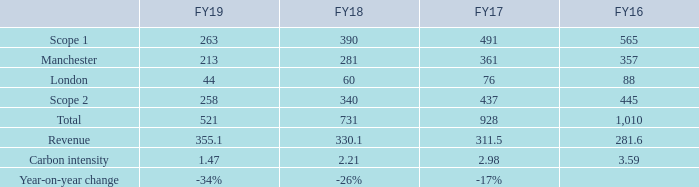Total CO2 emissions FY19
1 Tonnes of carbon dioxide equivalent.
2 Absolute carbon emissions divided by revenue in millions.
Auto Trader is required to measure and
report its direct and indirect greenhouse
gas (‘GHG’) emissions by the Companies Act
2006 (Strategic Report and Directors’ Report)
Regulations 2013. The greenhouse gas
reporting period is aligned to the financial
reporting year. The methodology used to
calculate our emissions is based on the
financial consolidation approach, as
defined in the Greenhouse Gas Protocol,
A Corporate Accounting and Reporting
Standard (Revised Edition). Emission
factors used are from UK government
(‘BEIS’) conversion factor guidance for
the year reported.
Auto Trader is required to measure and report its direct and indirect greenhouse gas (‘GHG’) emissions by the Companies Act 2006 (Strategic Report and Directors’ Report) Regulations 2013. The greenhouse gas reporting period is aligned to the financial reporting year. The methodology used to calculate our emissions is based on the financial consolidation approach, as defined in the Greenhouse Gas Protocol, A Corporate Accounting and Reporting Standard (Revised Edition). Emission factors used are from UK government (‘BEIS’) conversion factor guidance for the year reported.
The report includes the ‘Scope 1’ (combustion of fuel) in relation to company cars and ‘Scope 2’ (purchased electricity and gas) emissions associated with our offices. We have chosen to include the emissions associated with leased company cars in Scope 1, as we are responsible for these emissions.
We have chosen to present a revenue intensity ratio as this is a relevant indicator of our growth and is aligned with our business strategy. The reduction in our GHG emissions is due to a reduction in the fuel emissions from our company car fleet, as the fleet has reduced. We have also reduced the amount of electricity we use, and this coupled with a decrease in BEIS conversion factors has also contributed to our Scope 2 reduction.
What are the units used when representing the Total CO2 emissions? Tonnes of carbon dioxide equivalent. How is carbon intensity calculated? Absolute carbon emissions divided by revenue in millions. Which items in the table are used to calculate the carbon intensity? Total, revenue. In which year was the CO2 emissions amount in London largest? 88>76>60>44
Answer: fy16. What was the change in the CO2 emissions amount in London in 2019 from 2018? 44-60
Answer: -16. What was the percentage change in the CO2 emissions amount in London in 2019 from 2018?
Answer scale should be: percent. (44-60)/60
Answer: -26.67. 